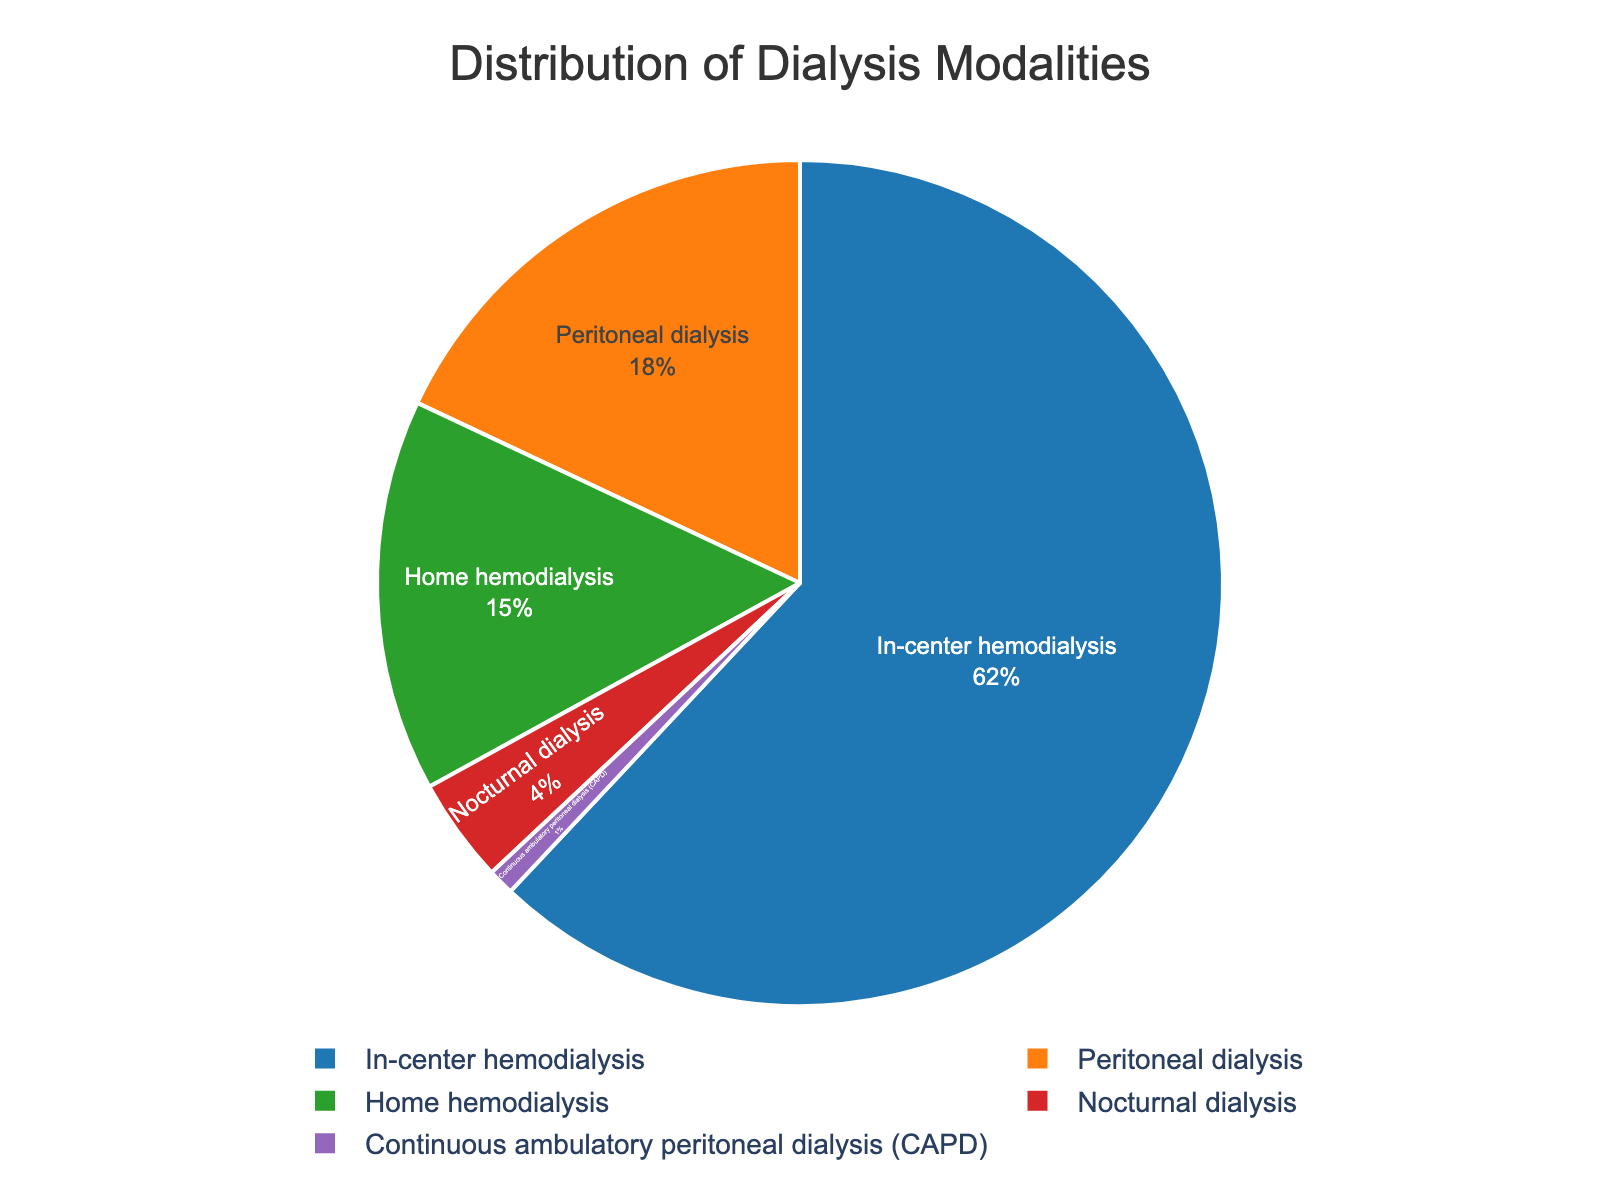What modality has the highest percentage of patients? The modality with the largest slice in the pie chart represents the highest percentage. The slice labeled "In-center hemodialysis" is the largest.
Answer: In-center hemodialysis How much more percentage does in-center hemodialysis have compared to nocturnal dialysis? Subtract the percentage of nocturnal dialysis (4%) from the percentage of in-center hemodialysis (62%). 62% - 4% = 58%.
Answer: 58% What is the combined percentage of patients undergoing home hemodialysis and peritoneal dialysis? Add the percentages of home hemodialysis (15%) and peritoneal dialysis (18%). 15% + 18% = 33%.
Answer: 33% Which modality represents the smallest portion of patients? The smallest slice of the pie chart corresponds to the modality with the smallest percentage. The slice labeled "Continuous ambulatory peritoneal dialysis (CAPD)" is the smallest.
Answer: Continuous ambulatory peritoneal dialysis (CAPD) What is the total percentage represented by home hemodialysis, peritoneal dialysis, and CAPD combined? Add the percentages of home hemodialysis (15%), peritoneal dialysis (18%), and CAPD (1%). 15% + 18% + 1% = 34%.
Answer: 34% Which modality has a higher percentage, home hemodialysis or peritoneal dialysis? Compare the percentages of home hemodialysis (15%) and peritoneal dialysis (18%). 18% is greater than 15%.
Answer: Peritoneal dialysis What percentage of patients are using dialysis at home (both home hemodialysis and peritoneal dialysis)? Add the percentages of home hemodialysis (15%) and peritoneal dialysis (18%). 15% + 18% = 33%.
Answer: 33% How does the percentage of nocturnal dialysis compare to home hemodialysis? Compare the percentages of home hemodialysis (15%) and nocturnal dialysis (4%). 15% is greater than 4%.
Answer: Home hemodialysis is greater What is the difference in percentage between peritoneal dialysis and home hemodialysis? Subtract the percentage of home hemodialysis (15%) from the percentage of peritoneal dialysis (18%). 18% - 15% = 3%.
Answer: 3% What is the average percentage of in-center hemodialysis, home hemodialysis, and peritoneal dialysis? Add the percentages of in-center hemodialysis (62%), home hemodialysis (15%), and peritoneal dialysis (18%), then divide by 3. (62% + 15% + 18%) / 3 = 95% / 3 ≈ 31.67%.
Answer: About 31.67% 